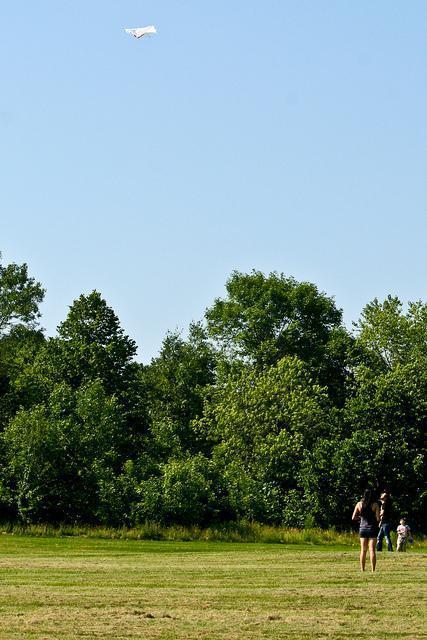How many people are there?
Give a very brief answer. 3. 